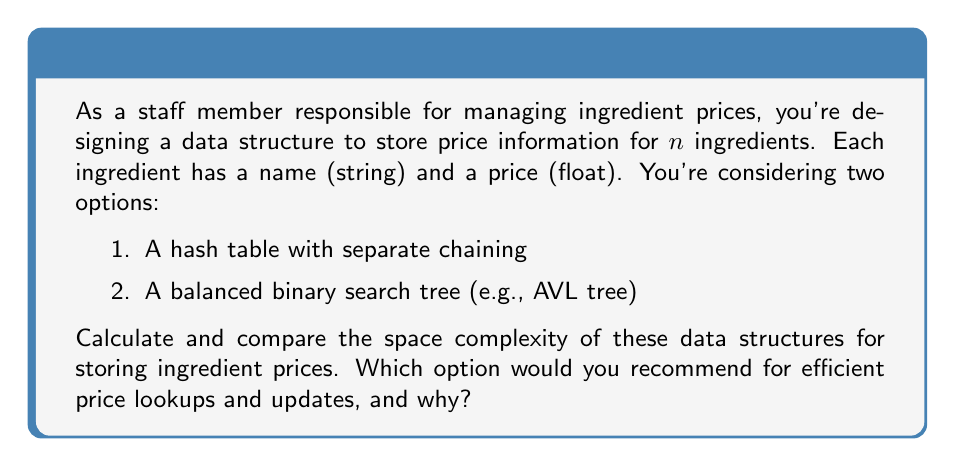Provide a solution to this math problem. Let's analyze the space complexity of both data structures:

1. Hash Table with Separate Chaining:
   - Space for storing $n$ key-value pairs: $O(n)$
   - Each entry contains:
     * Ingredient name (string): $O(m)$ where $m$ is the average length of ingredient names
     * Price (float): $O(1)$
     * Pointer to next element in the chain: $O(1)$
   - Total space: $O(n(m + 2))$ = $O(nm)$

   The hash table itself requires additional space:
   - Array of buckets: $O(k)$, where $k$ is the number of buckets (usually $k \approx n$)
   
   Overall space complexity: $O(nm + n) = O(nm)$

2. Balanced Binary Search Tree (AVL Tree):
   - Space for storing $n$ nodes: $O(n)$
   - Each node contains:
     * Ingredient name (string): $O(m)$
     * Price (float): $O(1)$
     * Left and right child pointers: $O(1)$ each
     * Height or balance factor: $O(1)$
   - Total space: $O(n(m + 4))$ = $O(nm)$

   Overall space complexity: $O(nm)$

Both data structures have the same asymptotic space complexity of $O(nm)$. However, the hash table might use slightly more memory due to the additional array of buckets.

For efficient price lookups and updates:
- Hash Table: Average-case $O(1)$ for both operations
- AVL Tree: $O(\log n)$ for both operations

Recommendation:
The hash table would be more efficient for lookups and updates, especially with a large number of ingredients. It offers constant-time average-case performance for both operations, which is better than the logarithmic time of the AVL tree.

However, if you need to maintain a sorted list of ingredients (e.g., for printing price lists in alphabetical order), the AVL tree would be more suitable, as it keeps elements sorted with no additional overhead.
Answer: Both data structures have a space complexity of $O(nm)$, where $n$ is the number of ingredients and $m$ is the average length of ingredient names. The hash table is recommended for efficient price lookups and updates due to its $O(1)$ average-case time complexity for these operations, compared to the AVL tree's $O(\log n)$ complexity. 